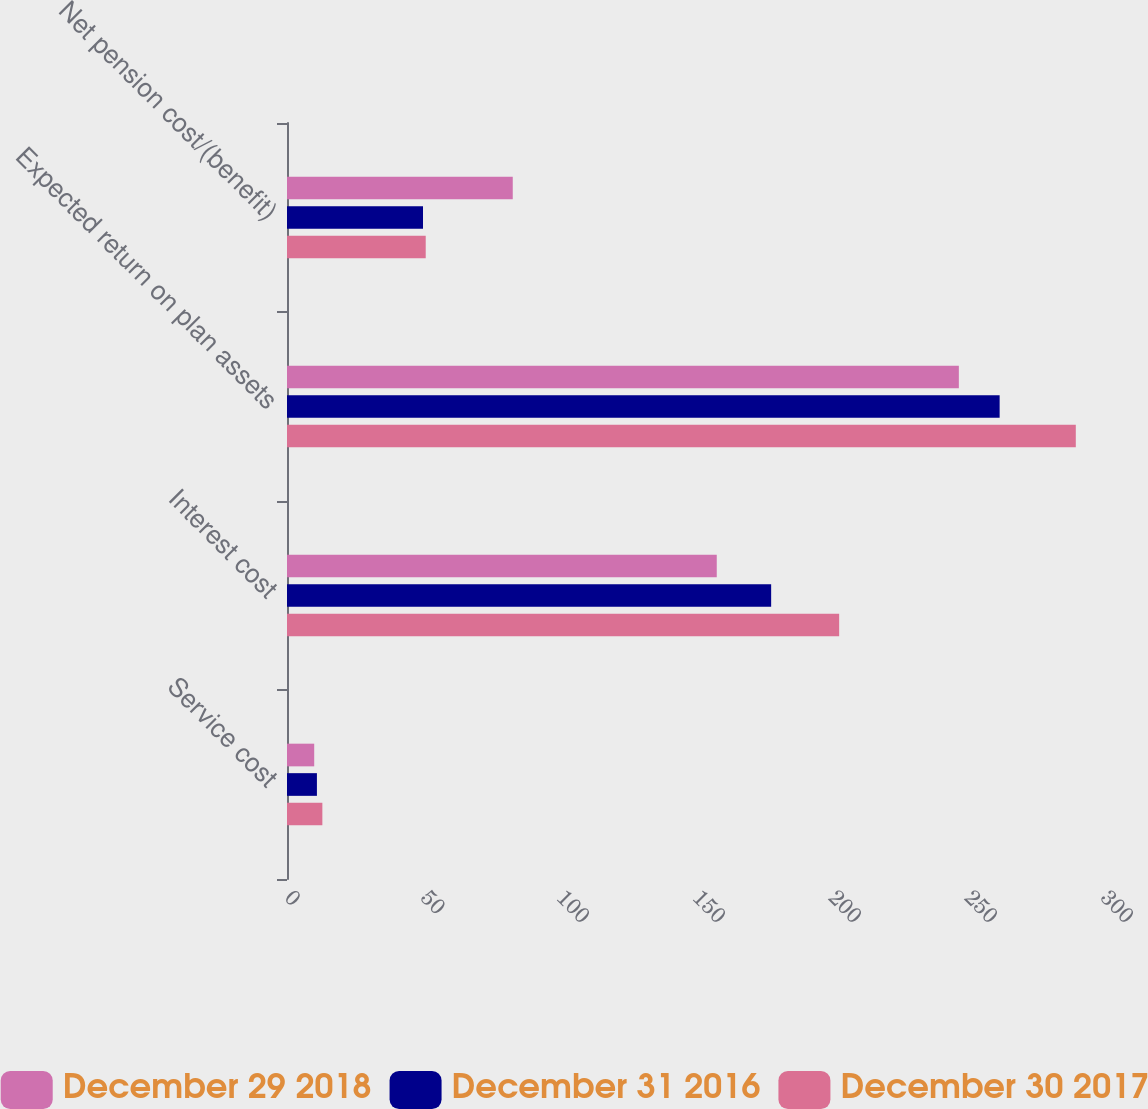Convert chart to OTSL. <chart><loc_0><loc_0><loc_500><loc_500><stacked_bar_chart><ecel><fcel>Service cost<fcel>Interest cost<fcel>Expected return on plan assets<fcel>Net pension cost/(benefit)<nl><fcel>December 29 2018<fcel>10<fcel>158<fcel>247<fcel>83<nl><fcel>December 31 2016<fcel>11<fcel>178<fcel>262<fcel>50<nl><fcel>December 30 2017<fcel>13<fcel>203<fcel>290<fcel>51<nl></chart> 